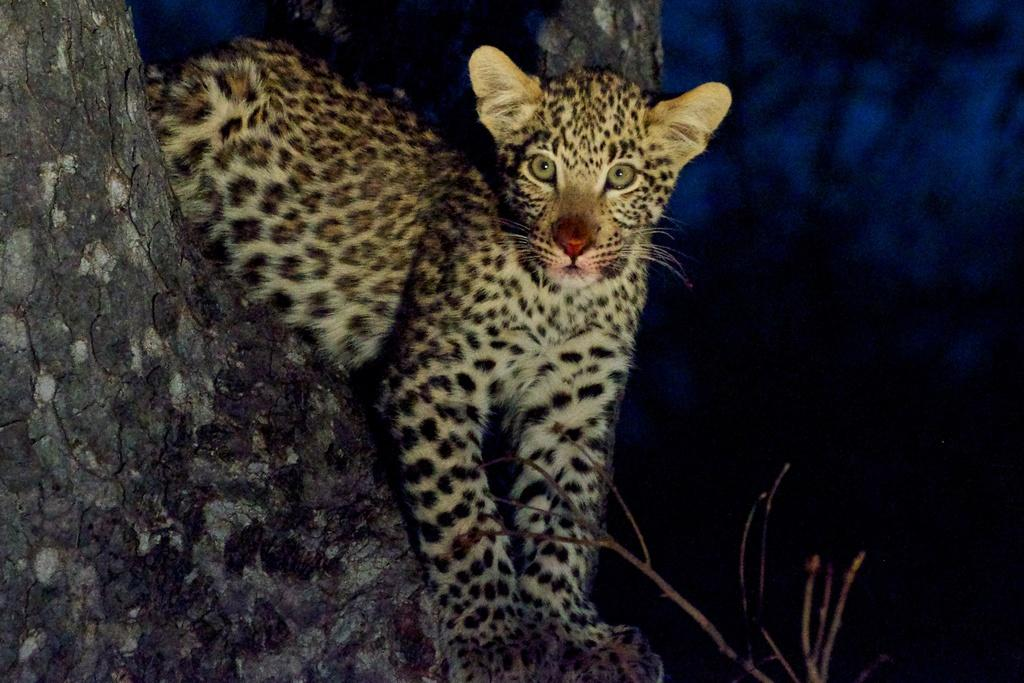What is on the tree in the image? There is an animal on a tree in the image. What part of the tree can be seen in the image? The tree trunk is visible in the image. What type of disease is affecting the animal's legs in the image? There is no indication of any disease or issue with the animal's legs in the image. How many bricks are visible on the tree in the image? There are no bricks present in the image; it features an animal on a tree and the tree trunk. 